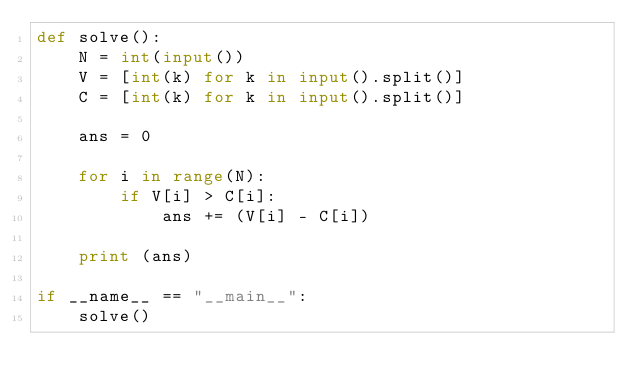<code> <loc_0><loc_0><loc_500><loc_500><_Python_>def solve():
    N = int(input())
    V = [int(k) for k in input().split()]
    C = [int(k) for k in input().split()]
    
    ans = 0
    
    for i in range(N):
        if V[i] > C[i]:
            ans += (V[i] - C[i])
    
    print (ans)
    
if __name__ == "__main__":
    solve()</code> 